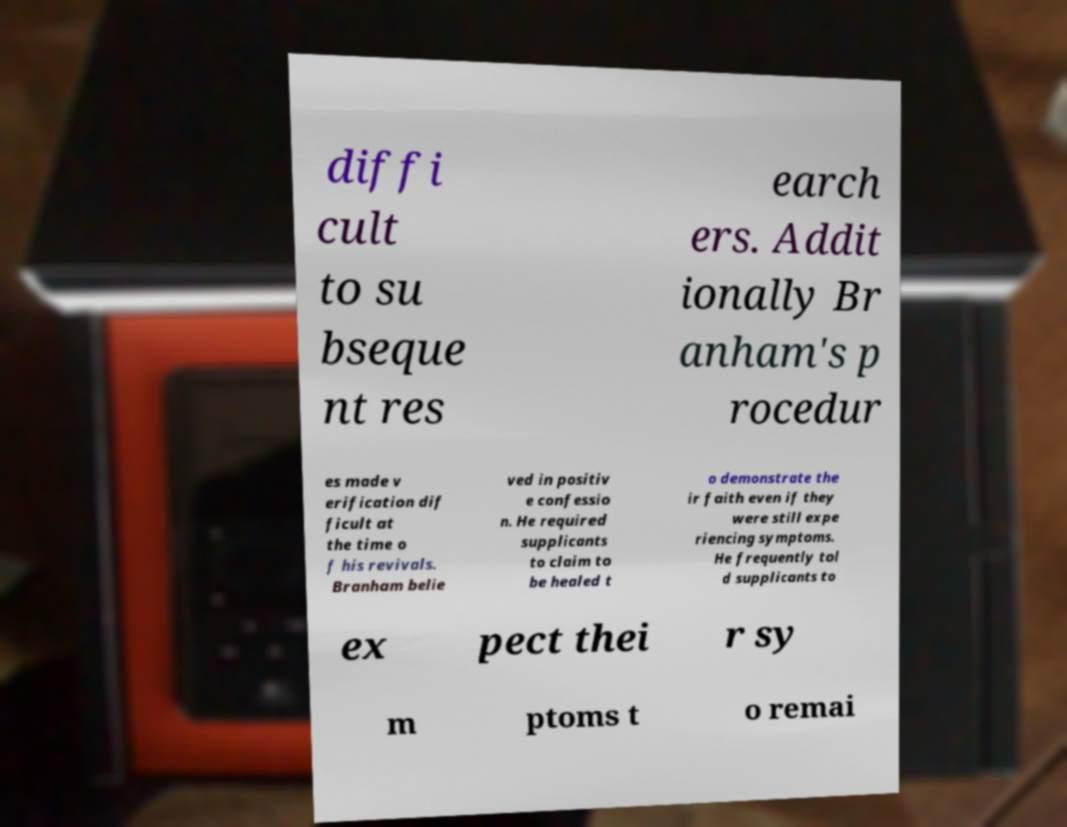Can you accurately transcribe the text from the provided image for me? diffi cult to su bseque nt res earch ers. Addit ionally Br anham's p rocedur es made v erification dif ficult at the time o f his revivals. Branham belie ved in positiv e confessio n. He required supplicants to claim to be healed t o demonstrate the ir faith even if they were still expe riencing symptoms. He frequently tol d supplicants to ex pect thei r sy m ptoms t o remai 